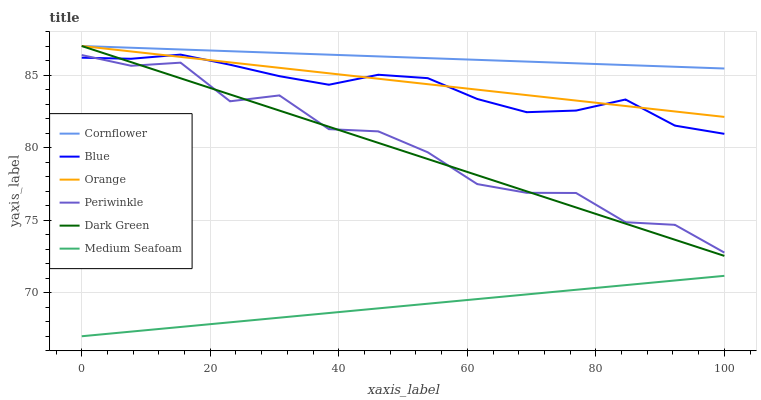Does Medium Seafoam have the minimum area under the curve?
Answer yes or no. Yes. Does Cornflower have the maximum area under the curve?
Answer yes or no. Yes. Does Periwinkle have the minimum area under the curve?
Answer yes or no. No. Does Periwinkle have the maximum area under the curve?
Answer yes or no. No. Is Cornflower the smoothest?
Answer yes or no. Yes. Is Periwinkle the roughest?
Answer yes or no. Yes. Is Periwinkle the smoothest?
Answer yes or no. No. Is Cornflower the roughest?
Answer yes or no. No. Does Medium Seafoam have the lowest value?
Answer yes or no. Yes. Does Periwinkle have the lowest value?
Answer yes or no. No. Does Dark Green have the highest value?
Answer yes or no. Yes. Does Periwinkle have the highest value?
Answer yes or no. No. Is Medium Seafoam less than Dark Green?
Answer yes or no. Yes. Is Cornflower greater than Medium Seafoam?
Answer yes or no. Yes. Does Orange intersect Blue?
Answer yes or no. Yes. Is Orange less than Blue?
Answer yes or no. No. Is Orange greater than Blue?
Answer yes or no. No. Does Medium Seafoam intersect Dark Green?
Answer yes or no. No. 